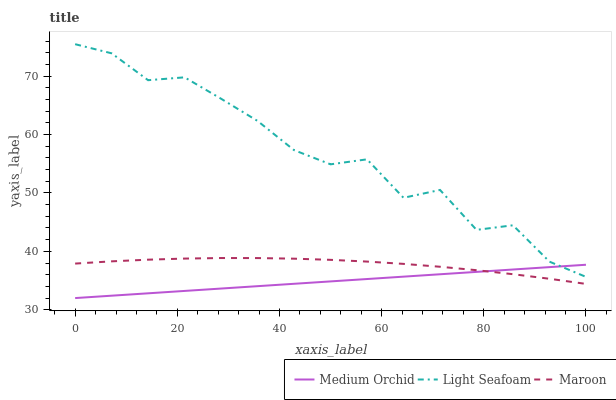Does Maroon have the minimum area under the curve?
Answer yes or no. No. Does Maroon have the maximum area under the curve?
Answer yes or no. No. Is Maroon the smoothest?
Answer yes or no. No. Is Maroon the roughest?
Answer yes or no. No. Does Maroon have the lowest value?
Answer yes or no. No. Does Maroon have the highest value?
Answer yes or no. No. Is Maroon less than Light Seafoam?
Answer yes or no. Yes. Is Light Seafoam greater than Maroon?
Answer yes or no. Yes. Does Maroon intersect Light Seafoam?
Answer yes or no. No. 